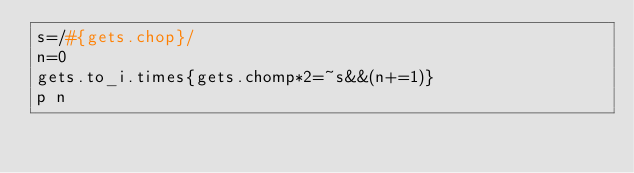Convert code to text. <code><loc_0><loc_0><loc_500><loc_500><_Ruby_>s=/#{gets.chop}/
n=0
gets.to_i.times{gets.chomp*2=~s&&(n+=1)}
p n</code> 